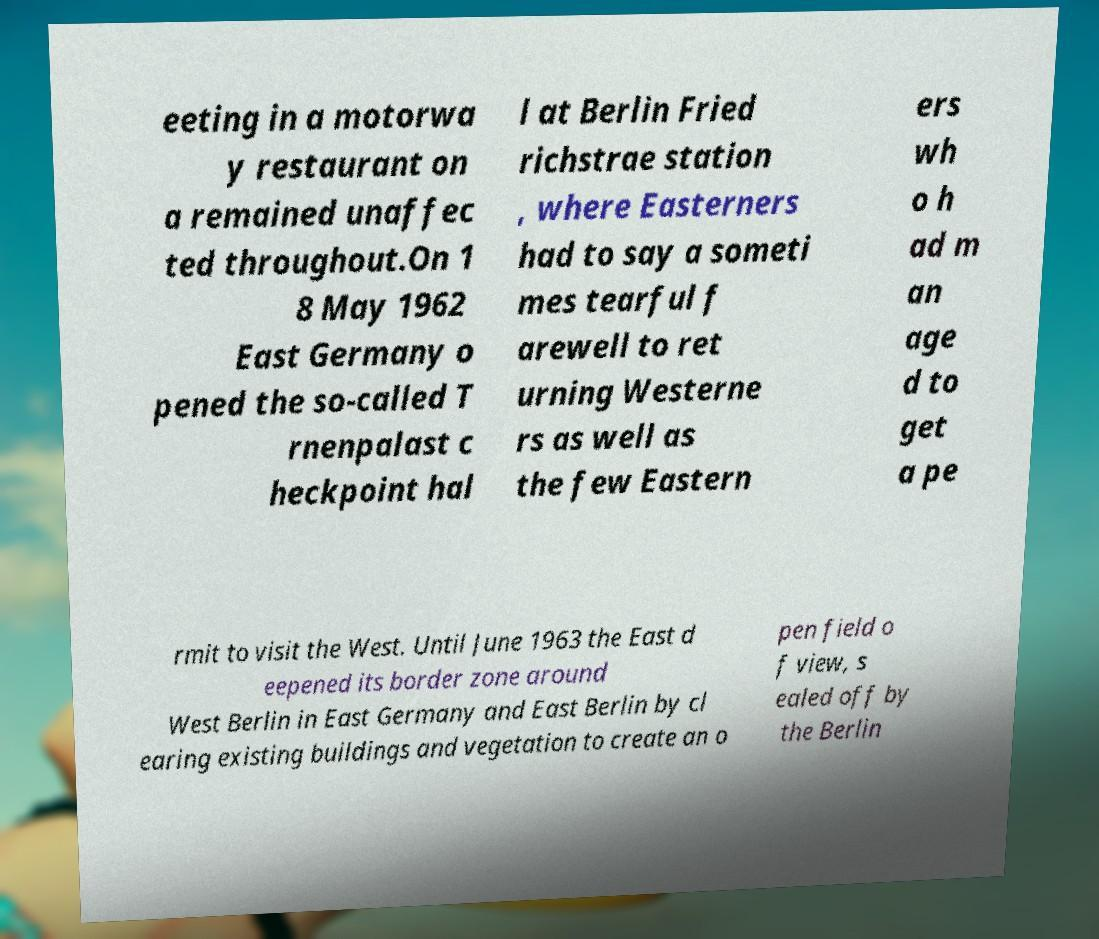Can you read and provide the text displayed in the image?This photo seems to have some interesting text. Can you extract and type it out for me? eeting in a motorwa y restaurant on a remained unaffec ted throughout.On 1 8 May 1962 East Germany o pened the so-called T rnenpalast c heckpoint hal l at Berlin Fried richstrae station , where Easterners had to say a someti mes tearful f arewell to ret urning Westerne rs as well as the few Eastern ers wh o h ad m an age d to get a pe rmit to visit the West. Until June 1963 the East d eepened its border zone around West Berlin in East Germany and East Berlin by cl earing existing buildings and vegetation to create an o pen field o f view, s ealed off by the Berlin 